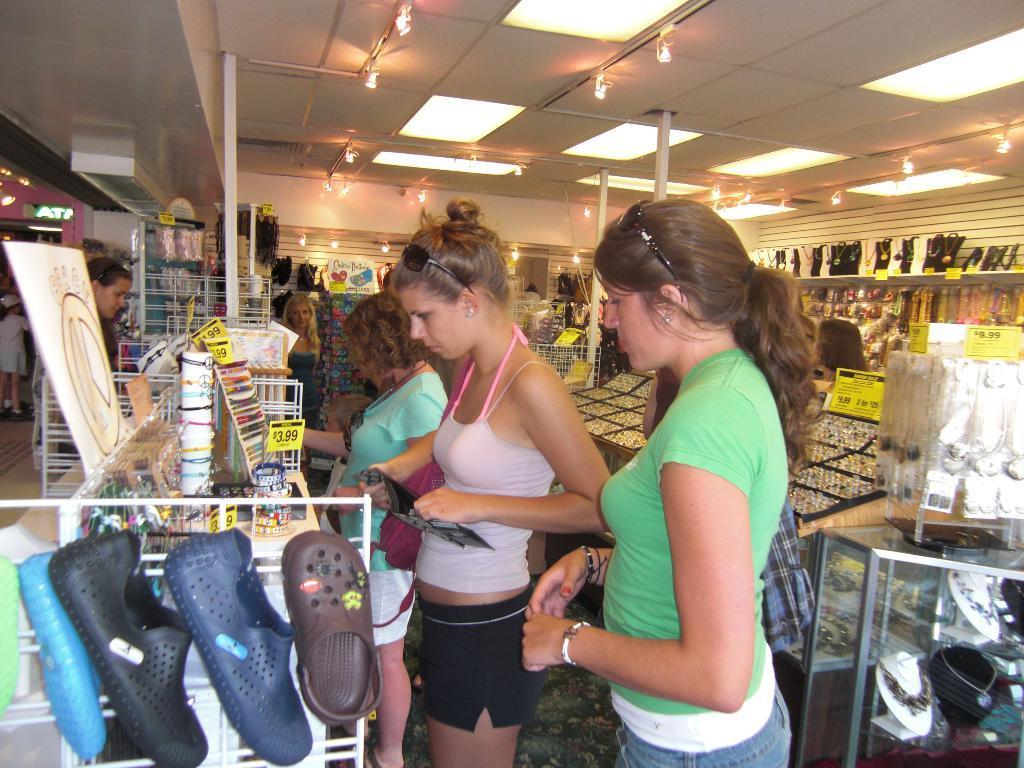In one or two sentences, can you explain what this image depicts? In the image we can see there are people standing and wearing clothes. Here we can see the store, floor and lights. Here we can see led text and in the store we can see there are many different things. 